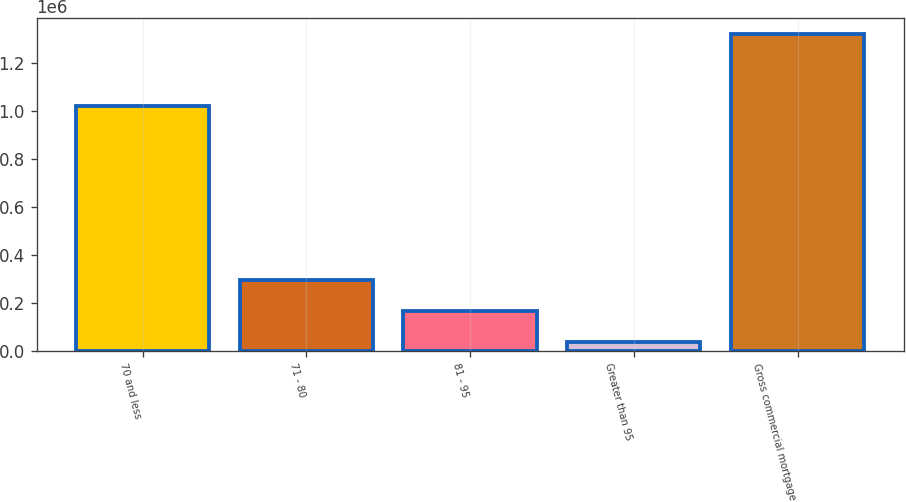<chart> <loc_0><loc_0><loc_500><loc_500><bar_chart><fcel>70 and less<fcel>71 - 80<fcel>81 - 95<fcel>Greater than 95<fcel>Gross commercial mortgage<nl><fcel>1.01893e+06<fcel>294177<fcel>165937<fcel>37697<fcel>1.3201e+06<nl></chart> 